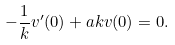<formula> <loc_0><loc_0><loc_500><loc_500>- \frac { 1 } { k } v ^ { \prime } ( 0 ) + a k v ( 0 ) = 0 .</formula> 